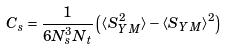<formula> <loc_0><loc_0><loc_500><loc_500>C _ { s } = \frac { 1 } { 6 N _ { s } ^ { 3 } N _ { t } } \left ( \langle S _ { Y M } ^ { 2 } \rangle - \langle S _ { Y M } \rangle ^ { 2 } \right )</formula> 